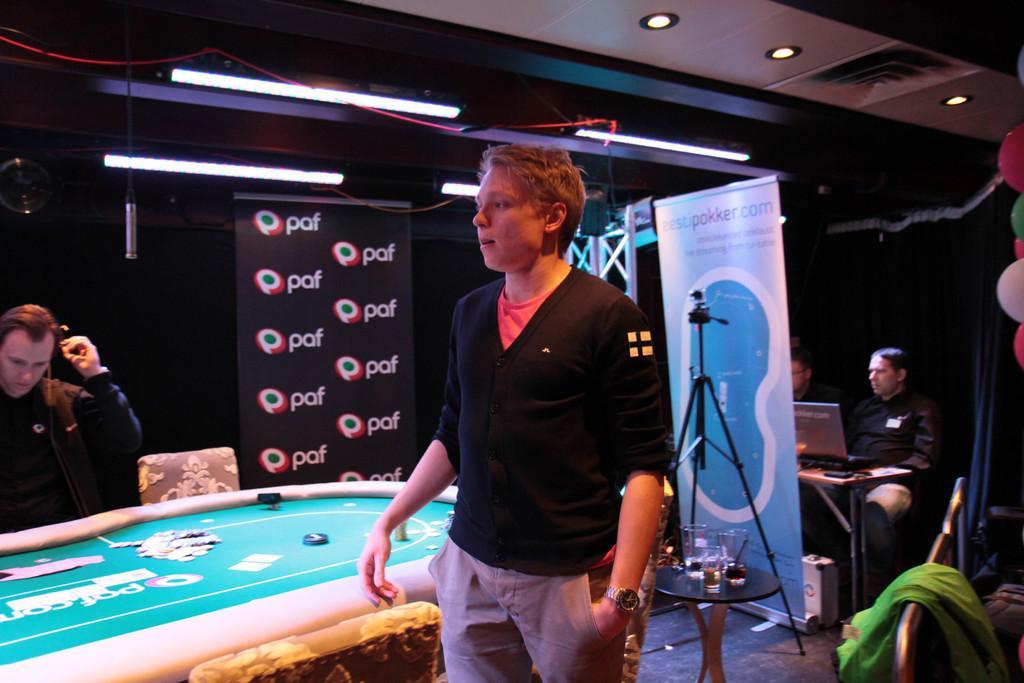How would you summarize this image in a sentence or two? In the middle there is a man he wear black t shirt ,trouser and watch. On the right there are two people sitting in front of the table. On the left there is a man he is staring at something. In the back ground there is a poster,stand ,camera ,table ,glasses ,lights and balloons. 